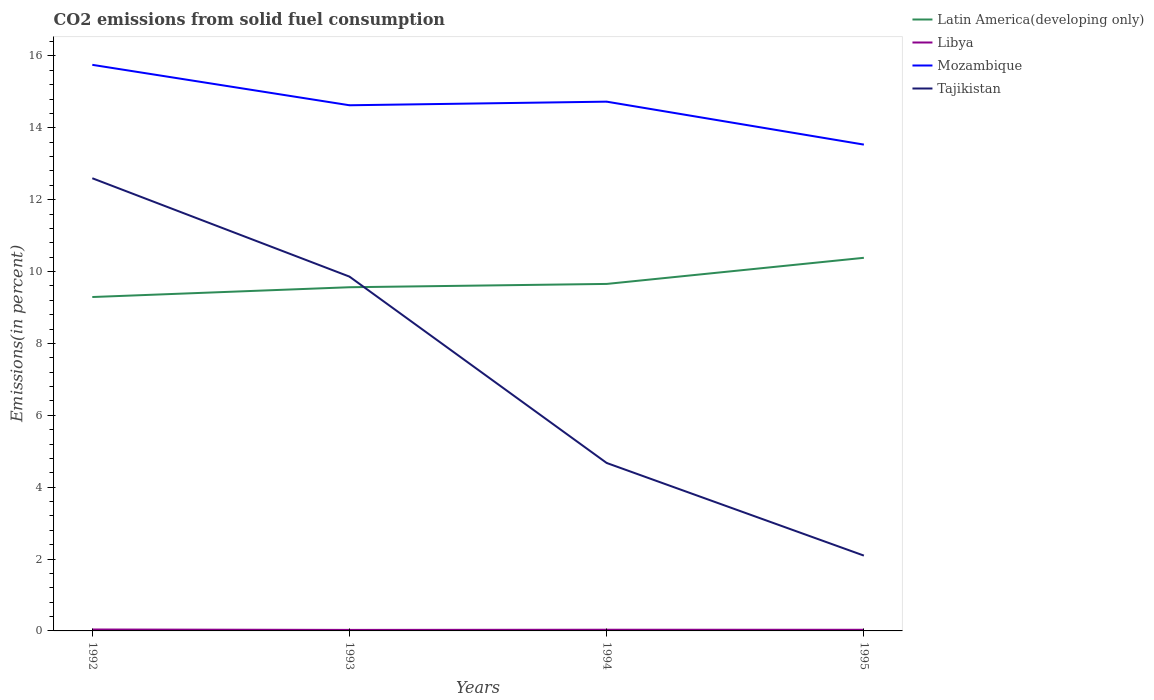How many different coloured lines are there?
Provide a short and direct response. 4. Is the number of lines equal to the number of legend labels?
Offer a very short reply. Yes. Across all years, what is the maximum total CO2 emitted in Mozambique?
Your answer should be compact. 13.53. In which year was the total CO2 emitted in Libya maximum?
Provide a succinct answer. 1993. What is the total total CO2 emitted in Libya in the graph?
Provide a short and direct response. 0.01. What is the difference between the highest and the second highest total CO2 emitted in Latin America(developing only)?
Offer a very short reply. 1.09. What is the difference between the highest and the lowest total CO2 emitted in Libya?
Provide a succinct answer. 2. Is the total CO2 emitted in Latin America(developing only) strictly greater than the total CO2 emitted in Mozambique over the years?
Keep it short and to the point. Yes. How many years are there in the graph?
Your answer should be very brief. 4. Does the graph contain any zero values?
Keep it short and to the point. No. How many legend labels are there?
Provide a succinct answer. 4. What is the title of the graph?
Give a very brief answer. CO2 emissions from solid fuel consumption. Does "Estonia" appear as one of the legend labels in the graph?
Give a very brief answer. No. What is the label or title of the X-axis?
Provide a short and direct response. Years. What is the label or title of the Y-axis?
Offer a terse response. Emissions(in percent). What is the Emissions(in percent) of Latin America(developing only) in 1992?
Offer a terse response. 9.29. What is the Emissions(in percent) of Libya in 1992?
Provide a short and direct response. 0.04. What is the Emissions(in percent) of Mozambique in 1992?
Provide a succinct answer. 15.75. What is the Emissions(in percent) of Tajikistan in 1992?
Make the answer very short. 12.6. What is the Emissions(in percent) in Latin America(developing only) in 1993?
Keep it short and to the point. 9.56. What is the Emissions(in percent) in Libya in 1993?
Offer a terse response. 0.03. What is the Emissions(in percent) of Mozambique in 1993?
Your answer should be very brief. 14.63. What is the Emissions(in percent) in Tajikistan in 1993?
Provide a succinct answer. 9.86. What is the Emissions(in percent) in Latin America(developing only) in 1994?
Keep it short and to the point. 9.65. What is the Emissions(in percent) of Libya in 1994?
Your response must be concise. 0.03. What is the Emissions(in percent) in Mozambique in 1994?
Keep it short and to the point. 14.73. What is the Emissions(in percent) of Tajikistan in 1994?
Your response must be concise. 4.67. What is the Emissions(in percent) of Latin America(developing only) in 1995?
Offer a terse response. 10.38. What is the Emissions(in percent) of Libya in 1995?
Your answer should be very brief. 0.03. What is the Emissions(in percent) in Mozambique in 1995?
Make the answer very short. 13.53. What is the Emissions(in percent) in Tajikistan in 1995?
Ensure brevity in your answer.  2.1. Across all years, what is the maximum Emissions(in percent) of Latin America(developing only)?
Offer a very short reply. 10.38. Across all years, what is the maximum Emissions(in percent) in Libya?
Offer a terse response. 0.04. Across all years, what is the maximum Emissions(in percent) of Mozambique?
Provide a short and direct response. 15.75. Across all years, what is the maximum Emissions(in percent) of Tajikistan?
Offer a terse response. 12.6. Across all years, what is the minimum Emissions(in percent) of Latin America(developing only)?
Make the answer very short. 9.29. Across all years, what is the minimum Emissions(in percent) in Libya?
Your answer should be compact. 0.03. Across all years, what is the minimum Emissions(in percent) in Mozambique?
Offer a terse response. 13.53. Across all years, what is the minimum Emissions(in percent) of Tajikistan?
Give a very brief answer. 2.1. What is the total Emissions(in percent) in Latin America(developing only) in the graph?
Your response must be concise. 38.89. What is the total Emissions(in percent) in Libya in the graph?
Provide a succinct answer. 0.13. What is the total Emissions(in percent) of Mozambique in the graph?
Offer a very short reply. 58.63. What is the total Emissions(in percent) in Tajikistan in the graph?
Make the answer very short. 29.22. What is the difference between the Emissions(in percent) of Latin America(developing only) in 1992 and that in 1993?
Your answer should be very brief. -0.27. What is the difference between the Emissions(in percent) in Libya in 1992 and that in 1993?
Provide a short and direct response. 0.01. What is the difference between the Emissions(in percent) in Mozambique in 1992 and that in 1993?
Offer a very short reply. 1.13. What is the difference between the Emissions(in percent) of Tajikistan in 1992 and that in 1993?
Offer a very short reply. 2.74. What is the difference between the Emissions(in percent) of Latin America(developing only) in 1992 and that in 1994?
Offer a terse response. -0.36. What is the difference between the Emissions(in percent) in Libya in 1992 and that in 1994?
Make the answer very short. 0.01. What is the difference between the Emissions(in percent) of Mozambique in 1992 and that in 1994?
Your response must be concise. 1.02. What is the difference between the Emissions(in percent) in Tajikistan in 1992 and that in 1994?
Keep it short and to the point. 7.92. What is the difference between the Emissions(in percent) in Latin America(developing only) in 1992 and that in 1995?
Make the answer very short. -1.09. What is the difference between the Emissions(in percent) in Libya in 1992 and that in 1995?
Ensure brevity in your answer.  0.01. What is the difference between the Emissions(in percent) in Mozambique in 1992 and that in 1995?
Provide a short and direct response. 2.22. What is the difference between the Emissions(in percent) of Tajikistan in 1992 and that in 1995?
Provide a short and direct response. 10.5. What is the difference between the Emissions(in percent) of Latin America(developing only) in 1993 and that in 1994?
Offer a very short reply. -0.09. What is the difference between the Emissions(in percent) in Libya in 1993 and that in 1994?
Your response must be concise. -0.01. What is the difference between the Emissions(in percent) of Mozambique in 1993 and that in 1994?
Offer a very short reply. -0.1. What is the difference between the Emissions(in percent) of Tajikistan in 1993 and that in 1994?
Your answer should be compact. 5.19. What is the difference between the Emissions(in percent) in Latin America(developing only) in 1993 and that in 1995?
Provide a succinct answer. -0.82. What is the difference between the Emissions(in percent) in Libya in 1993 and that in 1995?
Provide a short and direct response. -0. What is the difference between the Emissions(in percent) in Mozambique in 1993 and that in 1995?
Offer a terse response. 1.09. What is the difference between the Emissions(in percent) of Tajikistan in 1993 and that in 1995?
Your response must be concise. 7.76. What is the difference between the Emissions(in percent) of Latin America(developing only) in 1994 and that in 1995?
Your response must be concise. -0.73. What is the difference between the Emissions(in percent) in Libya in 1994 and that in 1995?
Provide a short and direct response. 0. What is the difference between the Emissions(in percent) in Mozambique in 1994 and that in 1995?
Give a very brief answer. 1.19. What is the difference between the Emissions(in percent) of Tajikistan in 1994 and that in 1995?
Keep it short and to the point. 2.58. What is the difference between the Emissions(in percent) in Latin America(developing only) in 1992 and the Emissions(in percent) in Libya in 1993?
Your response must be concise. 9.26. What is the difference between the Emissions(in percent) of Latin America(developing only) in 1992 and the Emissions(in percent) of Mozambique in 1993?
Offer a terse response. -5.34. What is the difference between the Emissions(in percent) of Latin America(developing only) in 1992 and the Emissions(in percent) of Tajikistan in 1993?
Keep it short and to the point. -0.57. What is the difference between the Emissions(in percent) in Libya in 1992 and the Emissions(in percent) in Mozambique in 1993?
Your response must be concise. -14.59. What is the difference between the Emissions(in percent) of Libya in 1992 and the Emissions(in percent) of Tajikistan in 1993?
Ensure brevity in your answer.  -9.82. What is the difference between the Emissions(in percent) of Mozambique in 1992 and the Emissions(in percent) of Tajikistan in 1993?
Your answer should be very brief. 5.89. What is the difference between the Emissions(in percent) of Latin America(developing only) in 1992 and the Emissions(in percent) of Libya in 1994?
Provide a succinct answer. 9.26. What is the difference between the Emissions(in percent) in Latin America(developing only) in 1992 and the Emissions(in percent) in Mozambique in 1994?
Give a very brief answer. -5.44. What is the difference between the Emissions(in percent) of Latin America(developing only) in 1992 and the Emissions(in percent) of Tajikistan in 1994?
Offer a very short reply. 4.62. What is the difference between the Emissions(in percent) in Libya in 1992 and the Emissions(in percent) in Mozambique in 1994?
Ensure brevity in your answer.  -14.69. What is the difference between the Emissions(in percent) in Libya in 1992 and the Emissions(in percent) in Tajikistan in 1994?
Keep it short and to the point. -4.63. What is the difference between the Emissions(in percent) of Mozambique in 1992 and the Emissions(in percent) of Tajikistan in 1994?
Ensure brevity in your answer.  11.08. What is the difference between the Emissions(in percent) in Latin America(developing only) in 1992 and the Emissions(in percent) in Libya in 1995?
Offer a very short reply. 9.26. What is the difference between the Emissions(in percent) in Latin America(developing only) in 1992 and the Emissions(in percent) in Mozambique in 1995?
Give a very brief answer. -4.24. What is the difference between the Emissions(in percent) in Latin America(developing only) in 1992 and the Emissions(in percent) in Tajikistan in 1995?
Provide a succinct answer. 7.19. What is the difference between the Emissions(in percent) of Libya in 1992 and the Emissions(in percent) of Mozambique in 1995?
Your response must be concise. -13.49. What is the difference between the Emissions(in percent) in Libya in 1992 and the Emissions(in percent) in Tajikistan in 1995?
Keep it short and to the point. -2.06. What is the difference between the Emissions(in percent) of Mozambique in 1992 and the Emissions(in percent) of Tajikistan in 1995?
Make the answer very short. 13.66. What is the difference between the Emissions(in percent) in Latin America(developing only) in 1993 and the Emissions(in percent) in Libya in 1994?
Provide a succinct answer. 9.53. What is the difference between the Emissions(in percent) of Latin America(developing only) in 1993 and the Emissions(in percent) of Mozambique in 1994?
Provide a short and direct response. -5.16. What is the difference between the Emissions(in percent) in Latin America(developing only) in 1993 and the Emissions(in percent) in Tajikistan in 1994?
Ensure brevity in your answer.  4.89. What is the difference between the Emissions(in percent) in Libya in 1993 and the Emissions(in percent) in Mozambique in 1994?
Make the answer very short. -14.7. What is the difference between the Emissions(in percent) of Libya in 1993 and the Emissions(in percent) of Tajikistan in 1994?
Provide a succinct answer. -4.64. What is the difference between the Emissions(in percent) of Mozambique in 1993 and the Emissions(in percent) of Tajikistan in 1994?
Your answer should be very brief. 9.95. What is the difference between the Emissions(in percent) of Latin America(developing only) in 1993 and the Emissions(in percent) of Libya in 1995?
Give a very brief answer. 9.53. What is the difference between the Emissions(in percent) of Latin America(developing only) in 1993 and the Emissions(in percent) of Mozambique in 1995?
Provide a short and direct response. -3.97. What is the difference between the Emissions(in percent) in Latin America(developing only) in 1993 and the Emissions(in percent) in Tajikistan in 1995?
Keep it short and to the point. 7.47. What is the difference between the Emissions(in percent) in Libya in 1993 and the Emissions(in percent) in Mozambique in 1995?
Your answer should be very brief. -13.5. What is the difference between the Emissions(in percent) in Libya in 1993 and the Emissions(in percent) in Tajikistan in 1995?
Give a very brief answer. -2.07. What is the difference between the Emissions(in percent) of Mozambique in 1993 and the Emissions(in percent) of Tajikistan in 1995?
Your response must be concise. 12.53. What is the difference between the Emissions(in percent) of Latin America(developing only) in 1994 and the Emissions(in percent) of Libya in 1995?
Provide a short and direct response. 9.62. What is the difference between the Emissions(in percent) in Latin America(developing only) in 1994 and the Emissions(in percent) in Mozambique in 1995?
Keep it short and to the point. -3.88. What is the difference between the Emissions(in percent) of Latin America(developing only) in 1994 and the Emissions(in percent) of Tajikistan in 1995?
Keep it short and to the point. 7.56. What is the difference between the Emissions(in percent) in Libya in 1994 and the Emissions(in percent) in Mozambique in 1995?
Ensure brevity in your answer.  -13.5. What is the difference between the Emissions(in percent) of Libya in 1994 and the Emissions(in percent) of Tajikistan in 1995?
Your answer should be very brief. -2.06. What is the difference between the Emissions(in percent) in Mozambique in 1994 and the Emissions(in percent) in Tajikistan in 1995?
Provide a short and direct response. 12.63. What is the average Emissions(in percent) in Latin America(developing only) per year?
Ensure brevity in your answer.  9.72. What is the average Emissions(in percent) of Libya per year?
Keep it short and to the point. 0.03. What is the average Emissions(in percent) of Mozambique per year?
Provide a short and direct response. 14.66. What is the average Emissions(in percent) in Tajikistan per year?
Your response must be concise. 7.31. In the year 1992, what is the difference between the Emissions(in percent) of Latin America(developing only) and Emissions(in percent) of Libya?
Your response must be concise. 9.25. In the year 1992, what is the difference between the Emissions(in percent) in Latin America(developing only) and Emissions(in percent) in Mozambique?
Your response must be concise. -6.46. In the year 1992, what is the difference between the Emissions(in percent) in Latin America(developing only) and Emissions(in percent) in Tajikistan?
Keep it short and to the point. -3.3. In the year 1992, what is the difference between the Emissions(in percent) in Libya and Emissions(in percent) in Mozambique?
Provide a succinct answer. -15.71. In the year 1992, what is the difference between the Emissions(in percent) of Libya and Emissions(in percent) of Tajikistan?
Your response must be concise. -12.56. In the year 1992, what is the difference between the Emissions(in percent) in Mozambique and Emissions(in percent) in Tajikistan?
Make the answer very short. 3.16. In the year 1993, what is the difference between the Emissions(in percent) in Latin America(developing only) and Emissions(in percent) in Libya?
Provide a succinct answer. 9.53. In the year 1993, what is the difference between the Emissions(in percent) in Latin America(developing only) and Emissions(in percent) in Mozambique?
Offer a terse response. -5.06. In the year 1993, what is the difference between the Emissions(in percent) in Latin America(developing only) and Emissions(in percent) in Tajikistan?
Ensure brevity in your answer.  -0.3. In the year 1993, what is the difference between the Emissions(in percent) of Libya and Emissions(in percent) of Mozambique?
Make the answer very short. -14.6. In the year 1993, what is the difference between the Emissions(in percent) of Libya and Emissions(in percent) of Tajikistan?
Make the answer very short. -9.83. In the year 1993, what is the difference between the Emissions(in percent) in Mozambique and Emissions(in percent) in Tajikistan?
Your response must be concise. 4.77. In the year 1994, what is the difference between the Emissions(in percent) in Latin America(developing only) and Emissions(in percent) in Libya?
Give a very brief answer. 9.62. In the year 1994, what is the difference between the Emissions(in percent) in Latin America(developing only) and Emissions(in percent) in Mozambique?
Ensure brevity in your answer.  -5.07. In the year 1994, what is the difference between the Emissions(in percent) in Latin America(developing only) and Emissions(in percent) in Tajikistan?
Offer a very short reply. 4.98. In the year 1994, what is the difference between the Emissions(in percent) of Libya and Emissions(in percent) of Mozambique?
Offer a terse response. -14.69. In the year 1994, what is the difference between the Emissions(in percent) in Libya and Emissions(in percent) in Tajikistan?
Your answer should be compact. -4.64. In the year 1994, what is the difference between the Emissions(in percent) in Mozambique and Emissions(in percent) in Tajikistan?
Offer a terse response. 10.05. In the year 1995, what is the difference between the Emissions(in percent) of Latin America(developing only) and Emissions(in percent) of Libya?
Offer a very short reply. 10.35. In the year 1995, what is the difference between the Emissions(in percent) of Latin America(developing only) and Emissions(in percent) of Mozambique?
Provide a short and direct response. -3.15. In the year 1995, what is the difference between the Emissions(in percent) in Latin America(developing only) and Emissions(in percent) in Tajikistan?
Make the answer very short. 8.29. In the year 1995, what is the difference between the Emissions(in percent) in Libya and Emissions(in percent) in Mozambique?
Make the answer very short. -13.5. In the year 1995, what is the difference between the Emissions(in percent) of Libya and Emissions(in percent) of Tajikistan?
Your answer should be very brief. -2.06. In the year 1995, what is the difference between the Emissions(in percent) in Mozambique and Emissions(in percent) in Tajikistan?
Ensure brevity in your answer.  11.44. What is the ratio of the Emissions(in percent) of Latin America(developing only) in 1992 to that in 1993?
Your response must be concise. 0.97. What is the ratio of the Emissions(in percent) in Libya in 1992 to that in 1993?
Your answer should be very brief. 1.39. What is the ratio of the Emissions(in percent) in Tajikistan in 1992 to that in 1993?
Offer a very short reply. 1.28. What is the ratio of the Emissions(in percent) of Latin America(developing only) in 1992 to that in 1994?
Make the answer very short. 0.96. What is the ratio of the Emissions(in percent) of Libya in 1992 to that in 1994?
Give a very brief answer. 1.18. What is the ratio of the Emissions(in percent) in Mozambique in 1992 to that in 1994?
Offer a terse response. 1.07. What is the ratio of the Emissions(in percent) of Tajikistan in 1992 to that in 1994?
Provide a succinct answer. 2.7. What is the ratio of the Emissions(in percent) of Latin America(developing only) in 1992 to that in 1995?
Provide a succinct answer. 0.89. What is the ratio of the Emissions(in percent) of Libya in 1992 to that in 1995?
Offer a terse response. 1.24. What is the ratio of the Emissions(in percent) of Mozambique in 1992 to that in 1995?
Offer a terse response. 1.16. What is the ratio of the Emissions(in percent) in Tajikistan in 1992 to that in 1995?
Provide a short and direct response. 6.01. What is the ratio of the Emissions(in percent) of Libya in 1993 to that in 1994?
Offer a terse response. 0.85. What is the ratio of the Emissions(in percent) in Tajikistan in 1993 to that in 1994?
Provide a short and direct response. 2.11. What is the ratio of the Emissions(in percent) in Latin America(developing only) in 1993 to that in 1995?
Your response must be concise. 0.92. What is the ratio of the Emissions(in percent) in Libya in 1993 to that in 1995?
Offer a terse response. 0.89. What is the ratio of the Emissions(in percent) of Mozambique in 1993 to that in 1995?
Make the answer very short. 1.08. What is the ratio of the Emissions(in percent) of Tajikistan in 1993 to that in 1995?
Your response must be concise. 4.7. What is the ratio of the Emissions(in percent) in Libya in 1994 to that in 1995?
Offer a very short reply. 1.04. What is the ratio of the Emissions(in percent) of Mozambique in 1994 to that in 1995?
Offer a very short reply. 1.09. What is the ratio of the Emissions(in percent) of Tajikistan in 1994 to that in 1995?
Your response must be concise. 2.23. What is the difference between the highest and the second highest Emissions(in percent) in Latin America(developing only)?
Your answer should be very brief. 0.73. What is the difference between the highest and the second highest Emissions(in percent) of Libya?
Provide a short and direct response. 0.01. What is the difference between the highest and the second highest Emissions(in percent) in Mozambique?
Keep it short and to the point. 1.02. What is the difference between the highest and the second highest Emissions(in percent) in Tajikistan?
Give a very brief answer. 2.74. What is the difference between the highest and the lowest Emissions(in percent) of Latin America(developing only)?
Make the answer very short. 1.09. What is the difference between the highest and the lowest Emissions(in percent) in Libya?
Your response must be concise. 0.01. What is the difference between the highest and the lowest Emissions(in percent) of Mozambique?
Your answer should be compact. 2.22. What is the difference between the highest and the lowest Emissions(in percent) in Tajikistan?
Your answer should be compact. 10.5. 